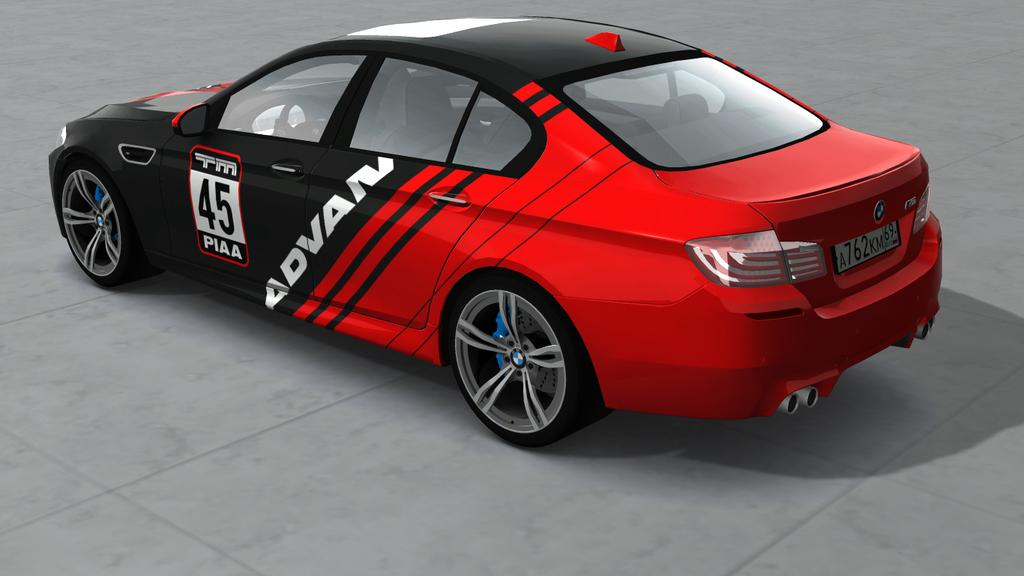What type of vehicle is in the image? There is a sports car in the image. What colors can be seen on the sports car? The sports car is black and red. Where is the sports car located in the image? The sports car is on the floor. How many tomatoes are hanging from the twig in the image? There are no tomatoes or twigs present in the image. What type of connection can be seen between the sports car and the floor in the image? There is no visible connection between the sports car and the floor in the image; the sports car is simply resting on the floor. 